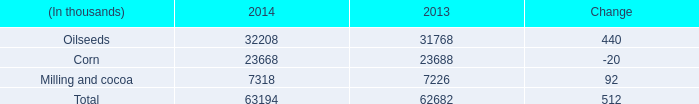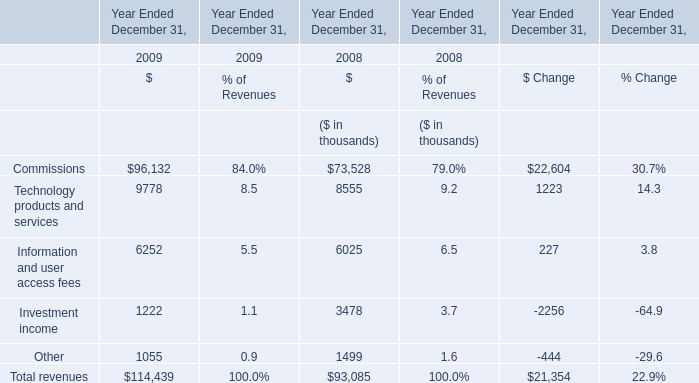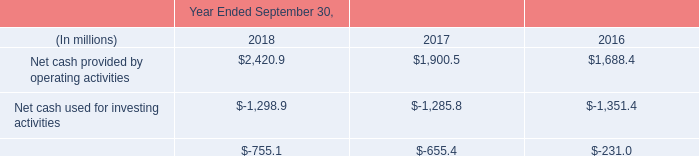What is the growing rate of Information and user access fees in the year where the percentage of Investment income in relation to Revenues is lower? 
Computations: ((6252 - 6025) / 6025)
Answer: 0.03768. 